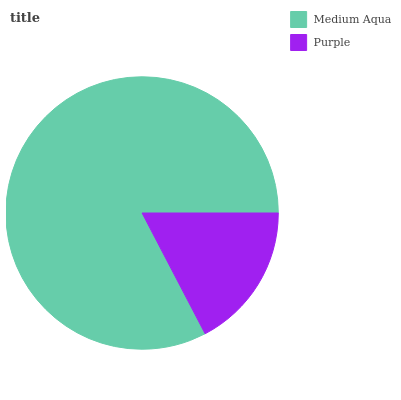Is Purple the minimum?
Answer yes or no. Yes. Is Medium Aqua the maximum?
Answer yes or no. Yes. Is Purple the maximum?
Answer yes or no. No. Is Medium Aqua greater than Purple?
Answer yes or no. Yes. Is Purple less than Medium Aqua?
Answer yes or no. Yes. Is Purple greater than Medium Aqua?
Answer yes or no. No. Is Medium Aqua less than Purple?
Answer yes or no. No. Is Medium Aqua the high median?
Answer yes or no. Yes. Is Purple the low median?
Answer yes or no. Yes. Is Purple the high median?
Answer yes or no. No. Is Medium Aqua the low median?
Answer yes or no. No. 